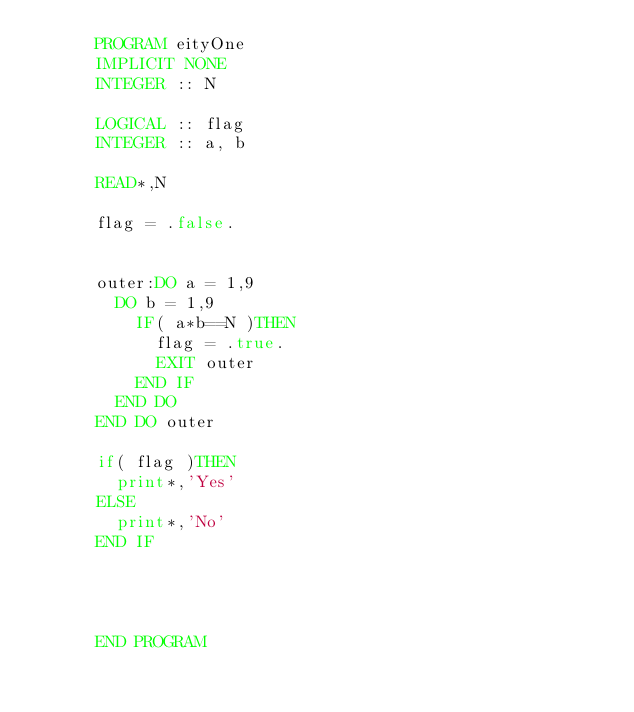<code> <loc_0><loc_0><loc_500><loc_500><_FORTRAN_>      PROGRAM eityOne
      IMPLICIT NONE
      INTEGER :: N
      
      LOGICAL :: flag
      INTEGER :: a, b
      
      READ*,N
      
      flag = .false.
      
      
      outer:DO a = 1,9
        DO b = 1,9
          IF( a*b==N )THEN
            flag = .true.
            EXIT outer
          END IF
        END DO
      END DO outer
      
      if( flag )THEN
        print*,'Yes'
      ELSE
        print*,'No'
      END IF
      
      
      
      
      END PROGRAM</code> 